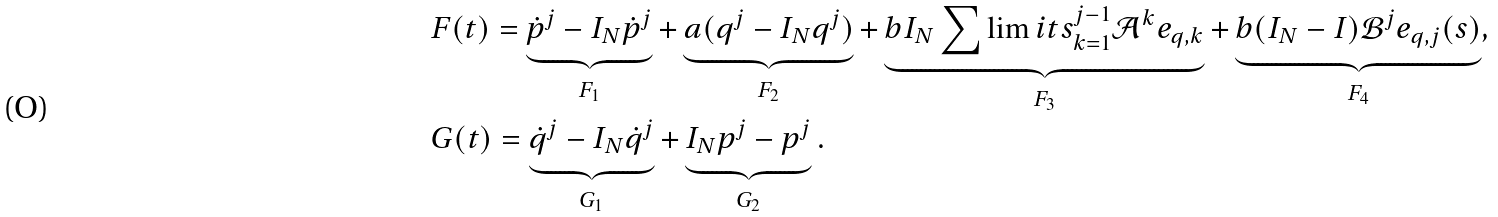Convert formula to latex. <formula><loc_0><loc_0><loc_500><loc_500>& F ( t ) = \underbrace { \dot { p } ^ { j } - I _ { N } { \dot { p } ^ { j } } } _ { F _ { 1 } } + \underbrace { a ( { q } ^ { j } - I _ { N } { q ^ { j } } ) } _ { F _ { 2 } } + \underbrace { b I _ { N } \sum \lim i t s _ { k = 1 } ^ { j - 1 } \mathcal { A } ^ { k } e _ { q , k } } _ { F _ { 3 } } + \underbrace { b ( I _ { N } - I ) \mathcal { B } ^ { j } e _ { q , j } ( s ) } _ { F _ { 4 } } , \\ & G ( t ) = \underbrace { \dot { q } ^ { j } - I _ { N } { \dot { q } ^ { j } } } _ { G _ { 1 } } + \underbrace { I _ { N } { p ^ { j } } - { p ^ { j } } } _ { G _ { 2 } } .</formula> 